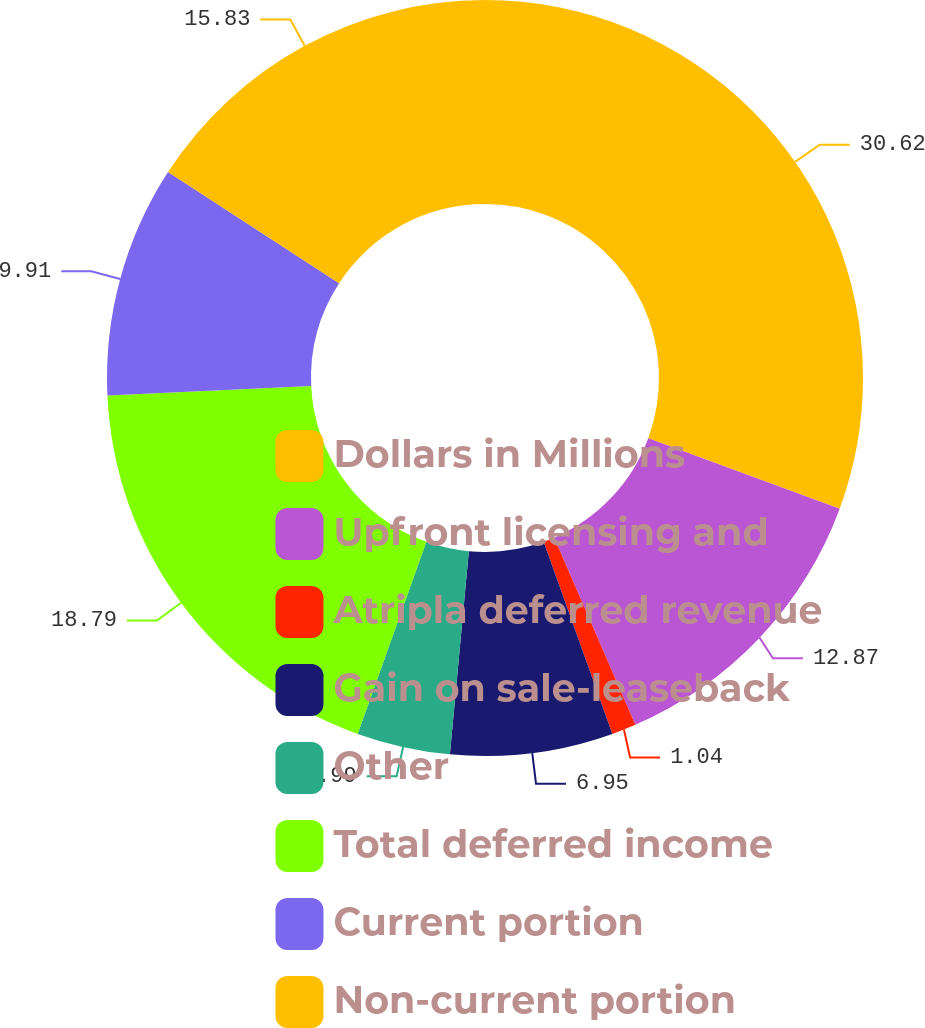Convert chart to OTSL. <chart><loc_0><loc_0><loc_500><loc_500><pie_chart><fcel>Dollars in Millions<fcel>Upfront licensing and<fcel>Atripla deferred revenue<fcel>Gain on sale-leaseback<fcel>Other<fcel>Total deferred income<fcel>Current portion<fcel>Non-current portion<nl><fcel>30.62%<fcel>12.87%<fcel>1.04%<fcel>6.95%<fcel>3.99%<fcel>18.79%<fcel>9.91%<fcel>15.83%<nl></chart> 